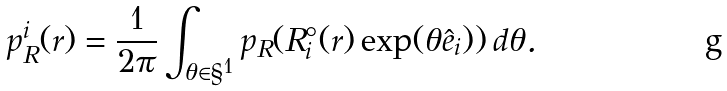<formula> <loc_0><loc_0><loc_500><loc_500>p _ { R } ^ { i } ( r ) = \frac { 1 } { 2 \pi } \int _ { \theta \in \S ^ { 1 } } p _ { R } ( R _ { i } ^ { \circ } ( r ) \exp ( \theta \hat { e } _ { i } ) ) \, d \theta .</formula> 